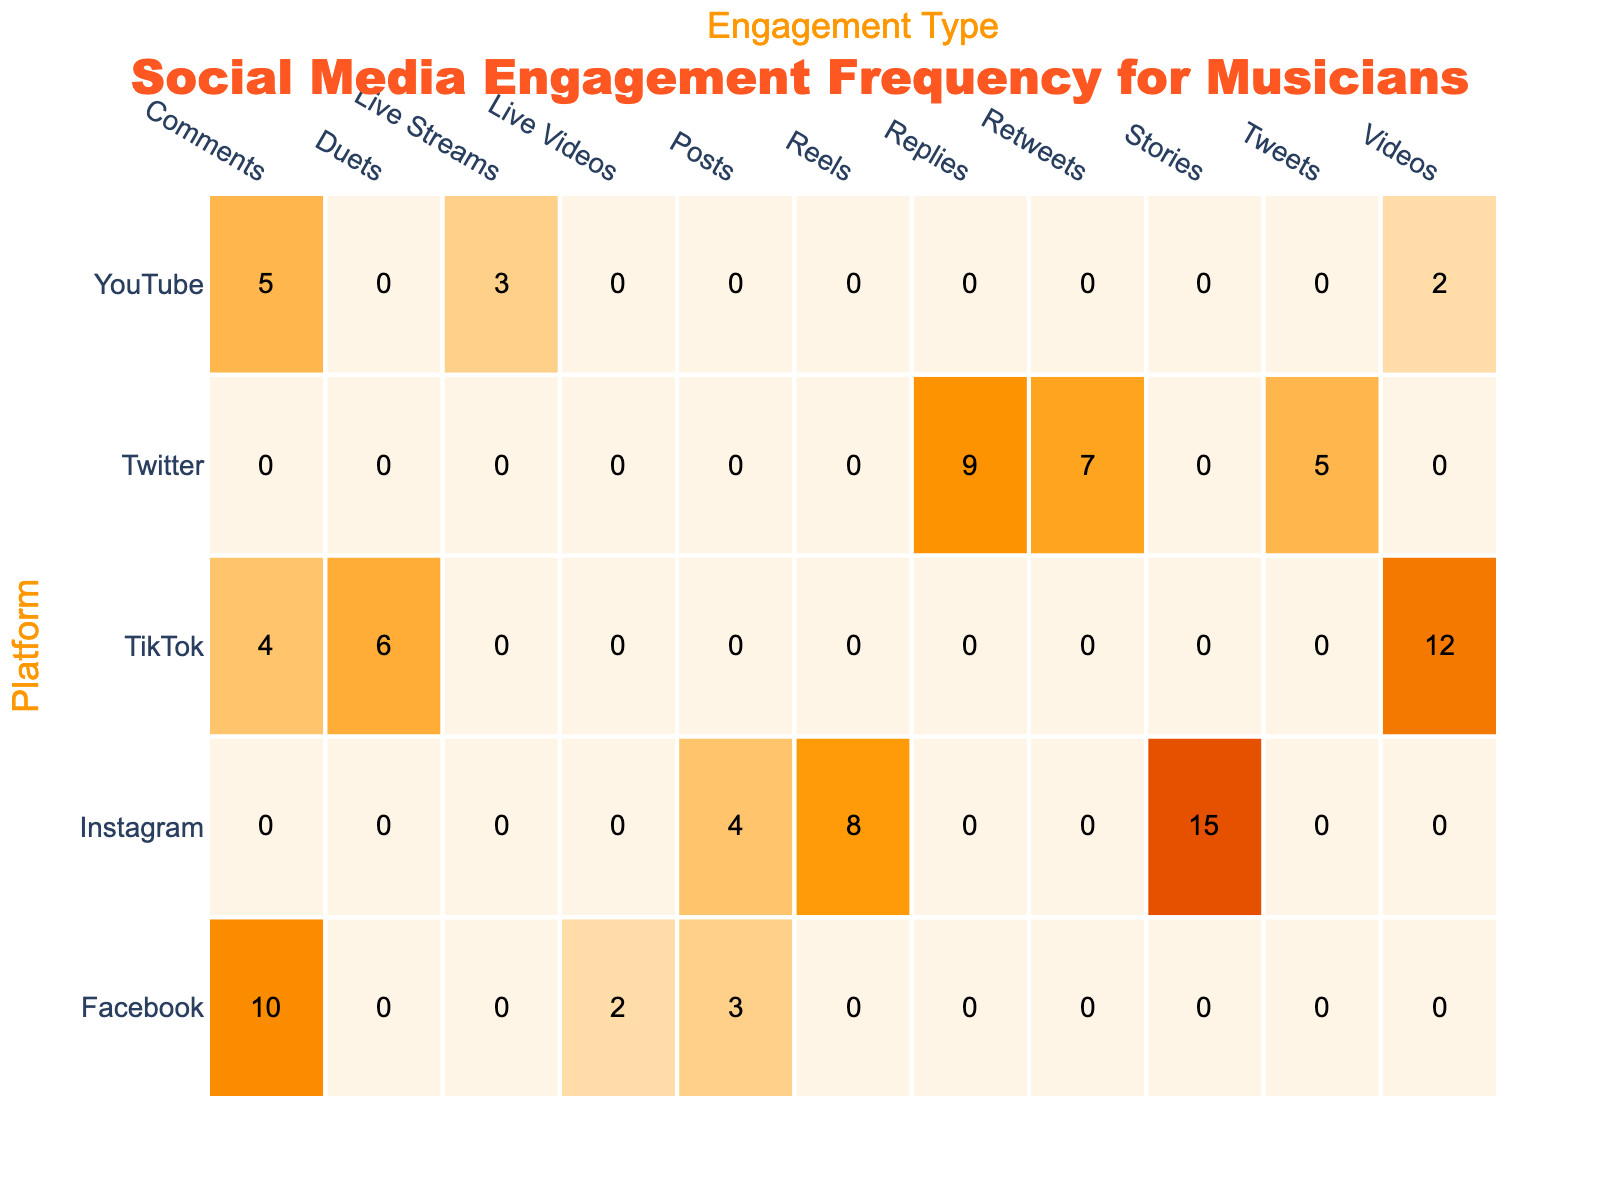What is the total frequency of engagement for Instagram? To find the total frequency for Instagram, I will sum the frequencies of all engagement types on this platform. The engagement types are: Posts (4), Stories (15), and Reels (8). So, 4 + 15 + 8 = 27.
Answer: 27 Which platform has the highest frequency of engagement for Posts? Looking at the frequencies for Posts across all platforms: Instagram has 4, Facebook has 3, Twitter has 5, TikTok has 0, and YouTube has 0. The highest frequency is 5 from Twitter.
Answer: Twitter Is there any engagement type on Facebook with a frequency greater than 5? The engagement types on Facebook are: Posts (3), Comments (10), and Live Videos (2). Only Comments has a frequency of 10, which is greater than 5.
Answer: Yes What is the average frequency of engagement across all platforms for Comments? There are three platforms with data for Comments: Facebook (10), TikTok (4), and YouTube (5). First, I sum these values: 10 + 4 + 5 = 19. Since there are three data points, the average will be 19 / 3 = 6.33.
Answer: 6.33 Which engagement type has the least frequency across all platforms? I will compare all engagement frequencies and identify the minimum. The lowest values from each type are: Posts (3), Comments (4), Live Videos (2), Tweets (5), Reels (8), and Duets (6). The minimum is from Live Videos with a frequency of 2.
Answer: Live Videos How many more engagement types does TikTok have compared to YouTube? TikTok has three engagement types: Videos (12), Duets (6), and Comments (4). YouTube has three as well: Videos (2), Comments (5), and Live Streams (3). Therefore, the difference is 3 - 3 = 0.
Answer: 0 Is the frequency of engagement types on Instagram always higher than on Facebook? I will compare the frequencies of engagement types: Instagram has Posts (4), Stories (15), Reels (8); Facebook has Posts (3), Comments (10), Live Videos (2). For each, Instagram's Posts (4 vs 3), Stories (15 vs 10), and Reels (8 vs 2) are indeed higher.
Answer: Yes What is the total engagement frequency for Twitter? To find the total frequency for Twitter, I will sum the frequencies of all engagement types: Tweets (5), Retweets (7), and Replies (9). Thus, the total is 5 + 7 + 9 = 21.
Answer: 21 Which platform has the second highest engagement frequency overall? I will first sum the total engagement frequencies per platform: Instagram (27), Facebook (15), Twitter (21), TikTok (22), and YouTube (10). The ranking is: 1st is Instagram (27), 2nd is TikTok (22).
Answer: TikTok 